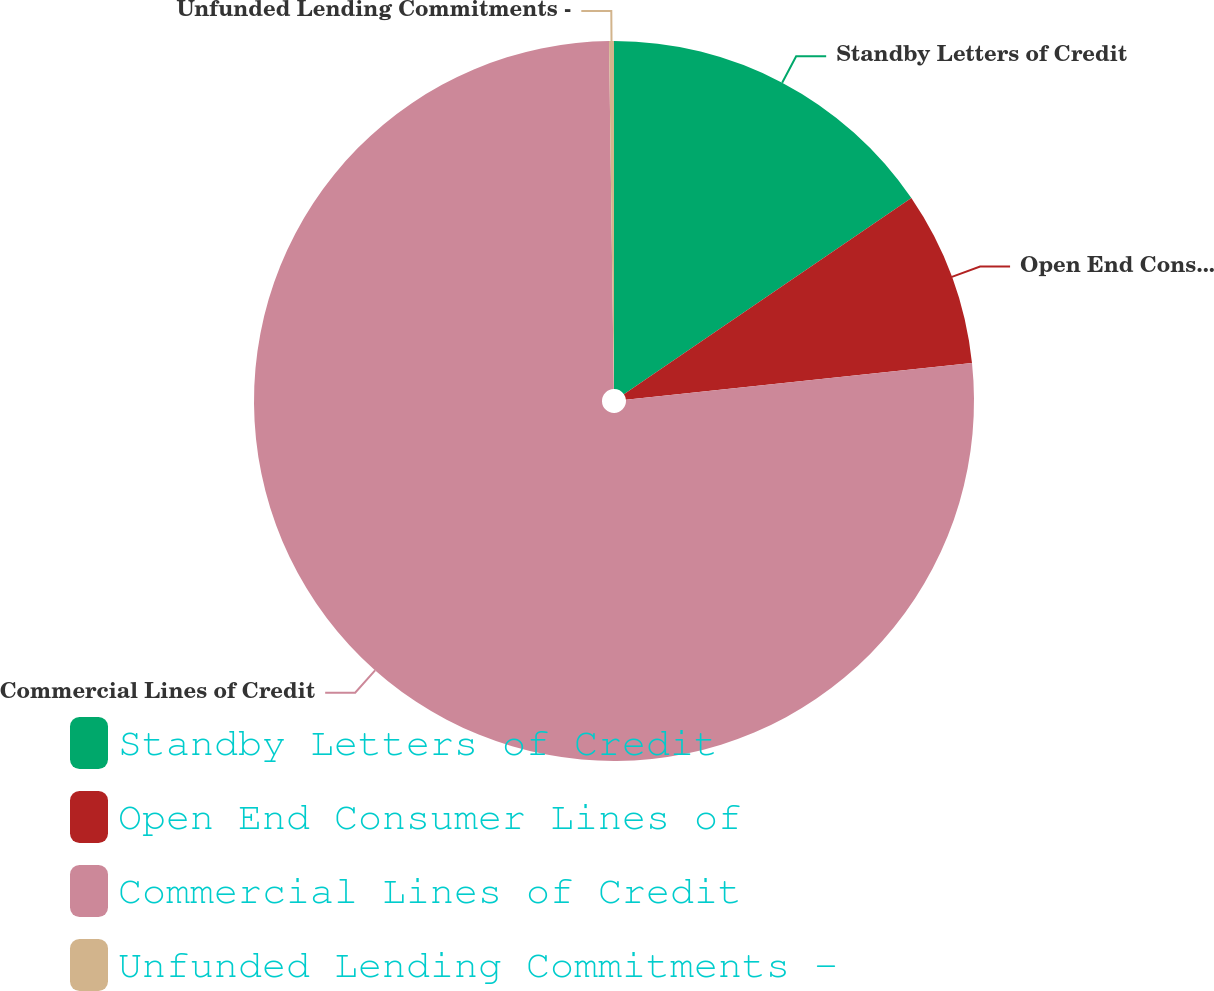<chart> <loc_0><loc_0><loc_500><loc_500><pie_chart><fcel>Standby Letters of Credit<fcel>Open End Consumer Lines of<fcel>Commercial Lines of Credit<fcel>Unfunded Lending Commitments -<nl><fcel>15.47%<fcel>7.85%<fcel>76.46%<fcel>0.22%<nl></chart> 